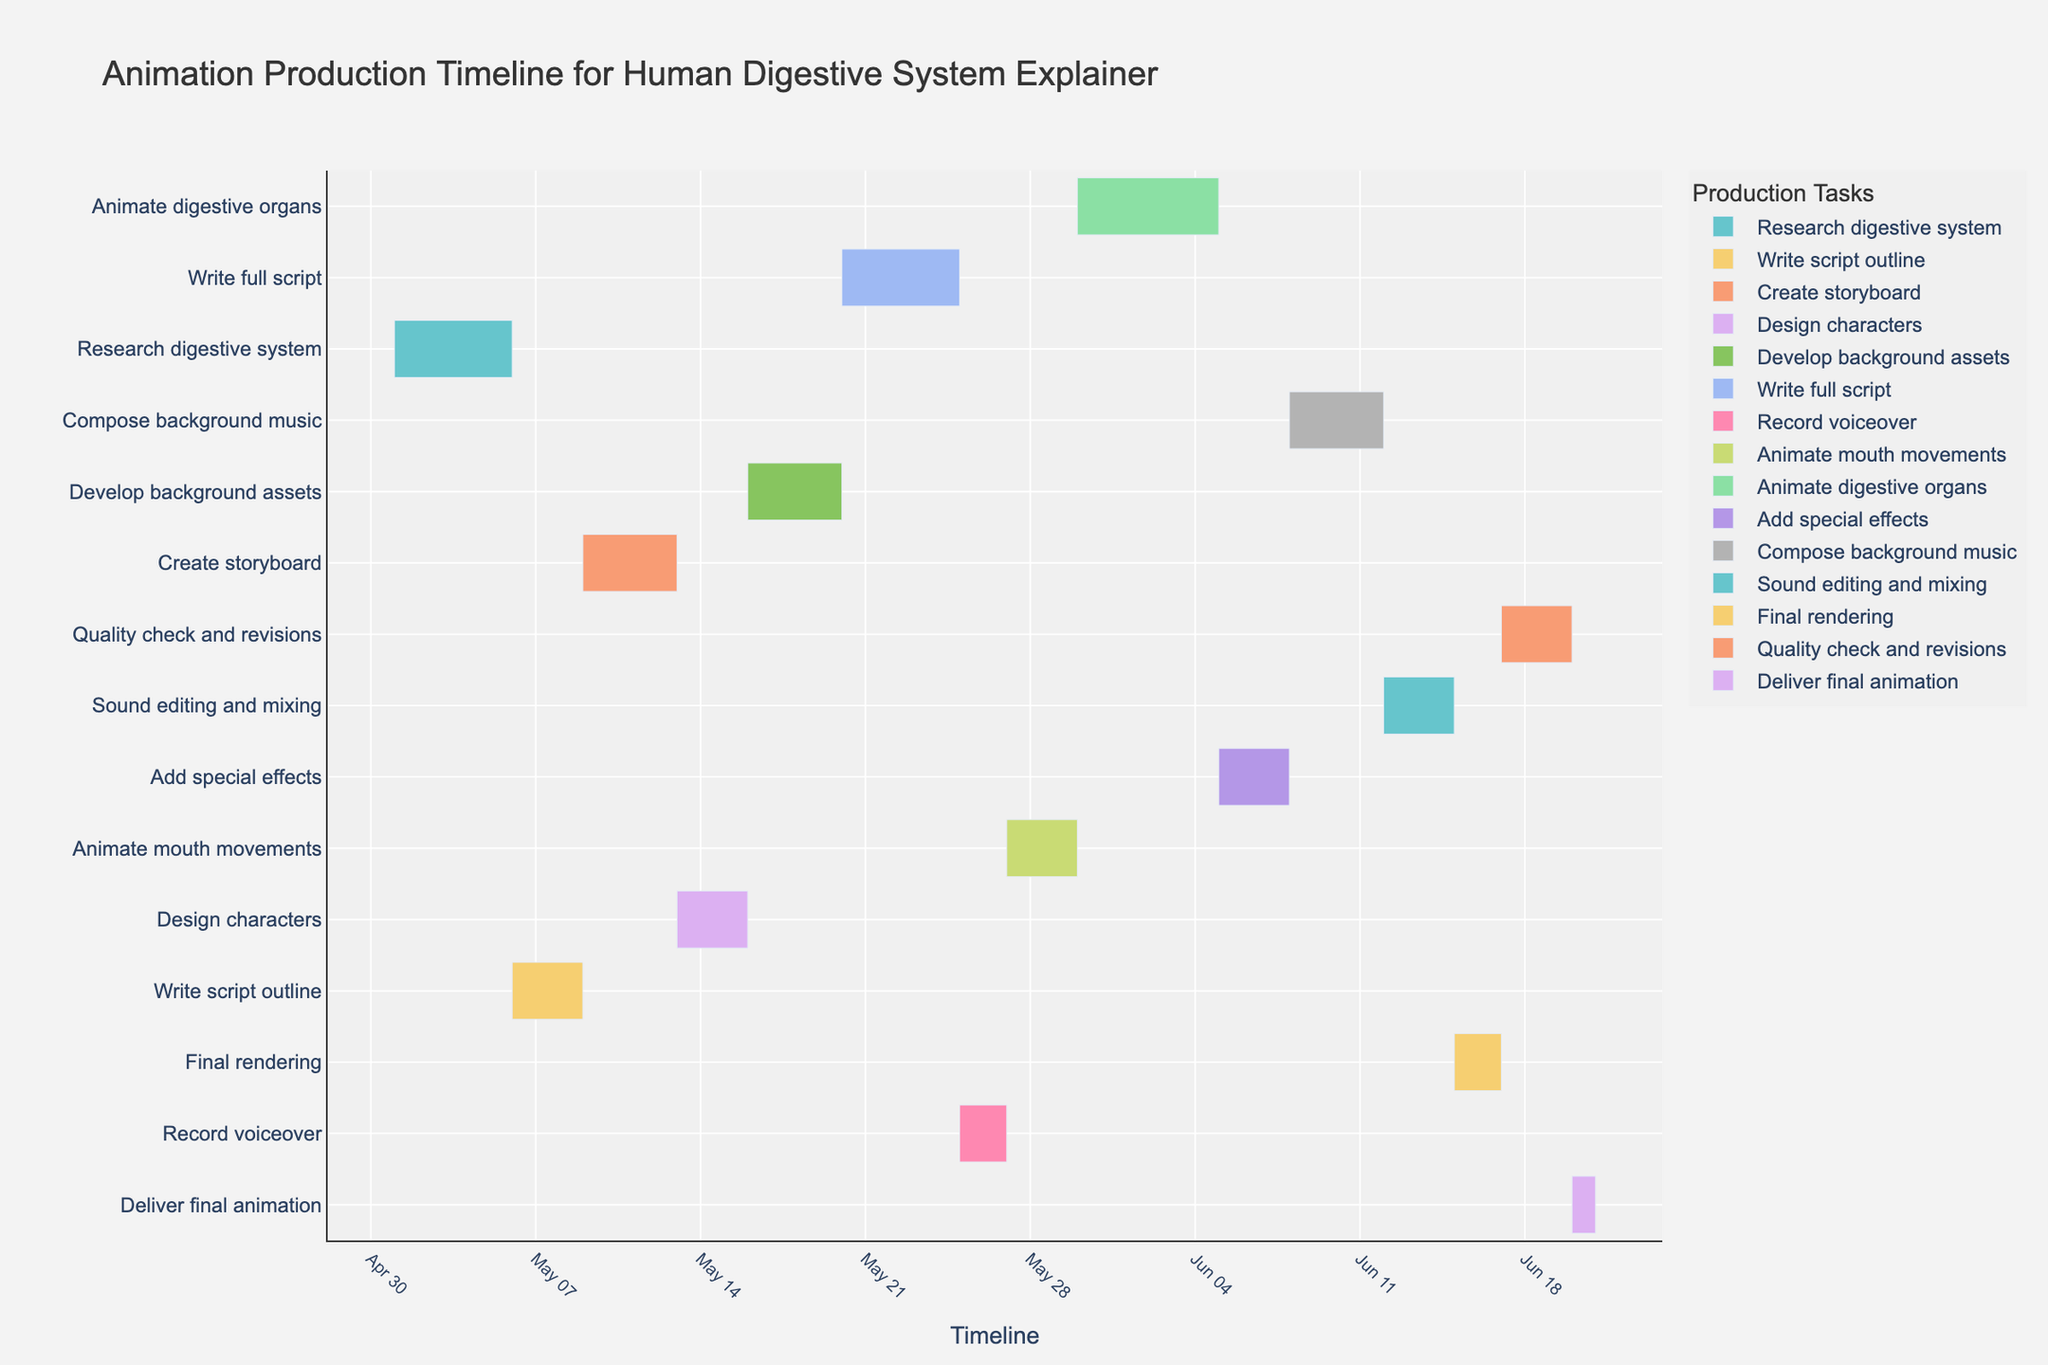what is the title of the figure? The title of the figure is located at the top of the chart. By reading the text, we can identify the title.
Answer: Animation Production Timeline for Human Digestive System Explainer what are the start and end dates for "Record voiceover"? By looking at the timeline for the "Record voiceover" task, we can see the start date at the left edge of the bar and the end date at the right edge of the bar.
Answer: Start: May 25, End: May 26 which task starts immediately after "Design characters"? To determine which task starts immediately after "Design characters", find when "Design characters" ends and look for the task that starts the next day. "Design characters" ends on May 15 and the next task is "Develop background assets" starting on May 16.
Answer: Develop background assets how many days are allocated to "Add special effects" and "Compose background music" combined? By examining the duration of each task, "Add special effects" takes 3 days and "Compose background music" takes 4 days. Summing these durations gives the total duration.
Answer: 7 days which task has the longest duration? By comparing the durations of all tasks, "Animate digestive organs" which is 6 days, has the longest duration.
Answer: Animate digestive organs how does the duration of "Write full script" compare with the duration of "Create storyboard"? "Write full script" has a duration of 5 days and "Create storyboard" has a duration of 4 days. Subtracting these values, we find that "Write full script" takes 1 day longer.
Answer: 1 day longer on which date does "Develop background assets" finish? To determine the end date of "Develop background assets," add the duration of 4 days to the start date of May 16. The task completes on May 19.
Answer: May 19 where does "Final rendering" appear in the sequence of tasks? By following the Gantt chart from top to bottom, we see that "Final rendering" is placed towards the end of the timeline. It starts on June 15.
Answer: Towards the end what is the total duration of all tasks combined? By summing the durations of all tasks provided in the figure (5 + 3 + 4 + 3 + 4 + 5 + 2 + 3 + 6 + 3 + 4 + 3 + 2 + 3 + 1), we get the total duration.
Answer: 47 days which task overlaps with "Animate mouth movements" for the longest time? Checking the overlap period for "Animate mouth movements" (May 27 - May 29), we see that "Animate digestive organs" overlaps from May 30, not during "Animate mouth movements". "Animate mouth movement's" timeline does not overlap significantly with other tasks, so no task overlaps for a long period.
Answer: None 